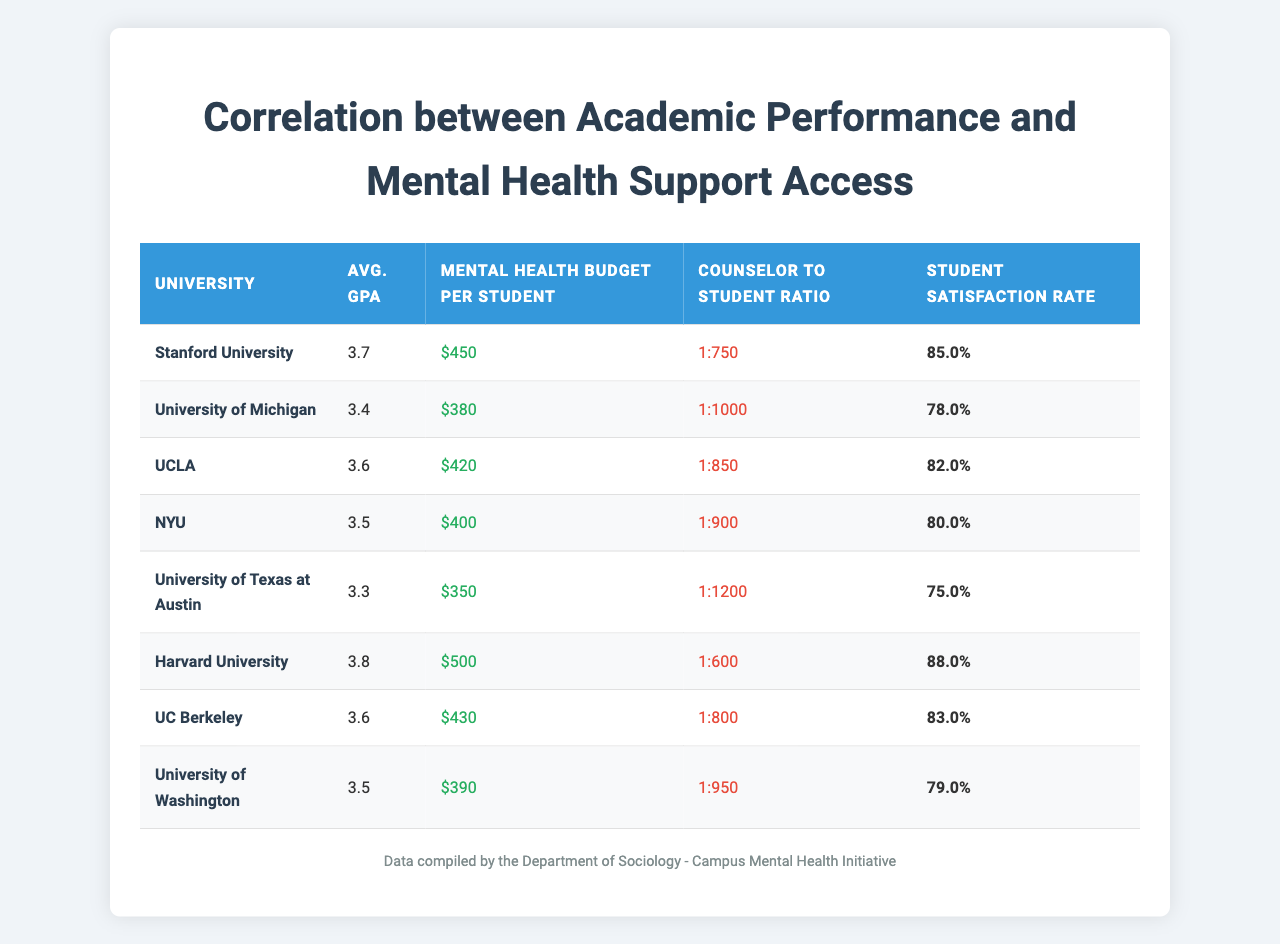What is the average GPA of Harvard University? The table lists Harvard University's average GPA as 3.8. This value is directly retrievable from the respective row for Harvard University in the table.
Answer: 3.8 Which university has the highest mental health budget per student? From the table, Harvard University has the highest mental health budget per student listed at $500. This can be found by comparing the budget values for all universities in the table.
Answer: Harvard University What is the counselor to student ratio at the University of Texas at Austin? According to the table, the counselor to student ratio at the University of Texas at Austin is 1:1200. This information can be found directly in the corresponding row for that university.
Answer: 1:1200 Is the student satisfaction rate at UCLA higher than that at the University of Michigan? The table shows UCLA's student satisfaction rate as 82% and the University of Michigan's as 78%. Since 82% is greater than 78%, the statement is true.
Answer: Yes What is the average mental health budget per student for the universities listed? To find the average, we sum the mental health budgets: (450 + 380 + 420 + 400 + 350 + 500 + 430 + 390) = 3220. There are 8 universities, so the average is 3220/8 = 402.5.
Answer: $402.5 How many universities have a student satisfaction rate of 80% or higher? The table indicates that Stanford (85%), UCLA (82%), Harvard (88%), and UC Berkeley (83%) all have satisfaction rates over 80%. Counting these universities yields a total of 4 universities.
Answer: 4 Which university has the lowest average GPA, and what is that GPA? From the table, the lowest average GPA is 3.3, which belongs to the University of Texas at Austin. This can be verified by comparing the average GPA values across all universities.
Answer: University of Texas at Austin, 3.3 What is the difference in student satisfaction between Stanford University and the University of Washington? Stanford's satisfaction rate is 85% and the University of Washington's is 79%. The difference is calculated as 85% - 79% = 6%.
Answer: 6% If we consider only universities with a counselor to student ratio less than 1:800, how many are there? The universities with a ratio less than 1:800 are Harvard (1:600), Stanford (1:750), and UC Berkeley (1:800). Thus, there are 3 universities that meet this criterion.
Answer: 3 Is the average budget of mental health services related to overall student satisfaction? To determine correlation, one would look at the values in the table. Higher budgets seem to align with higher satisfaction rates: Harvard, for example, has the highest budget and satisfaction. Therefore, one could argue they are positively correlated based on the data presented.
Answer: Yes 